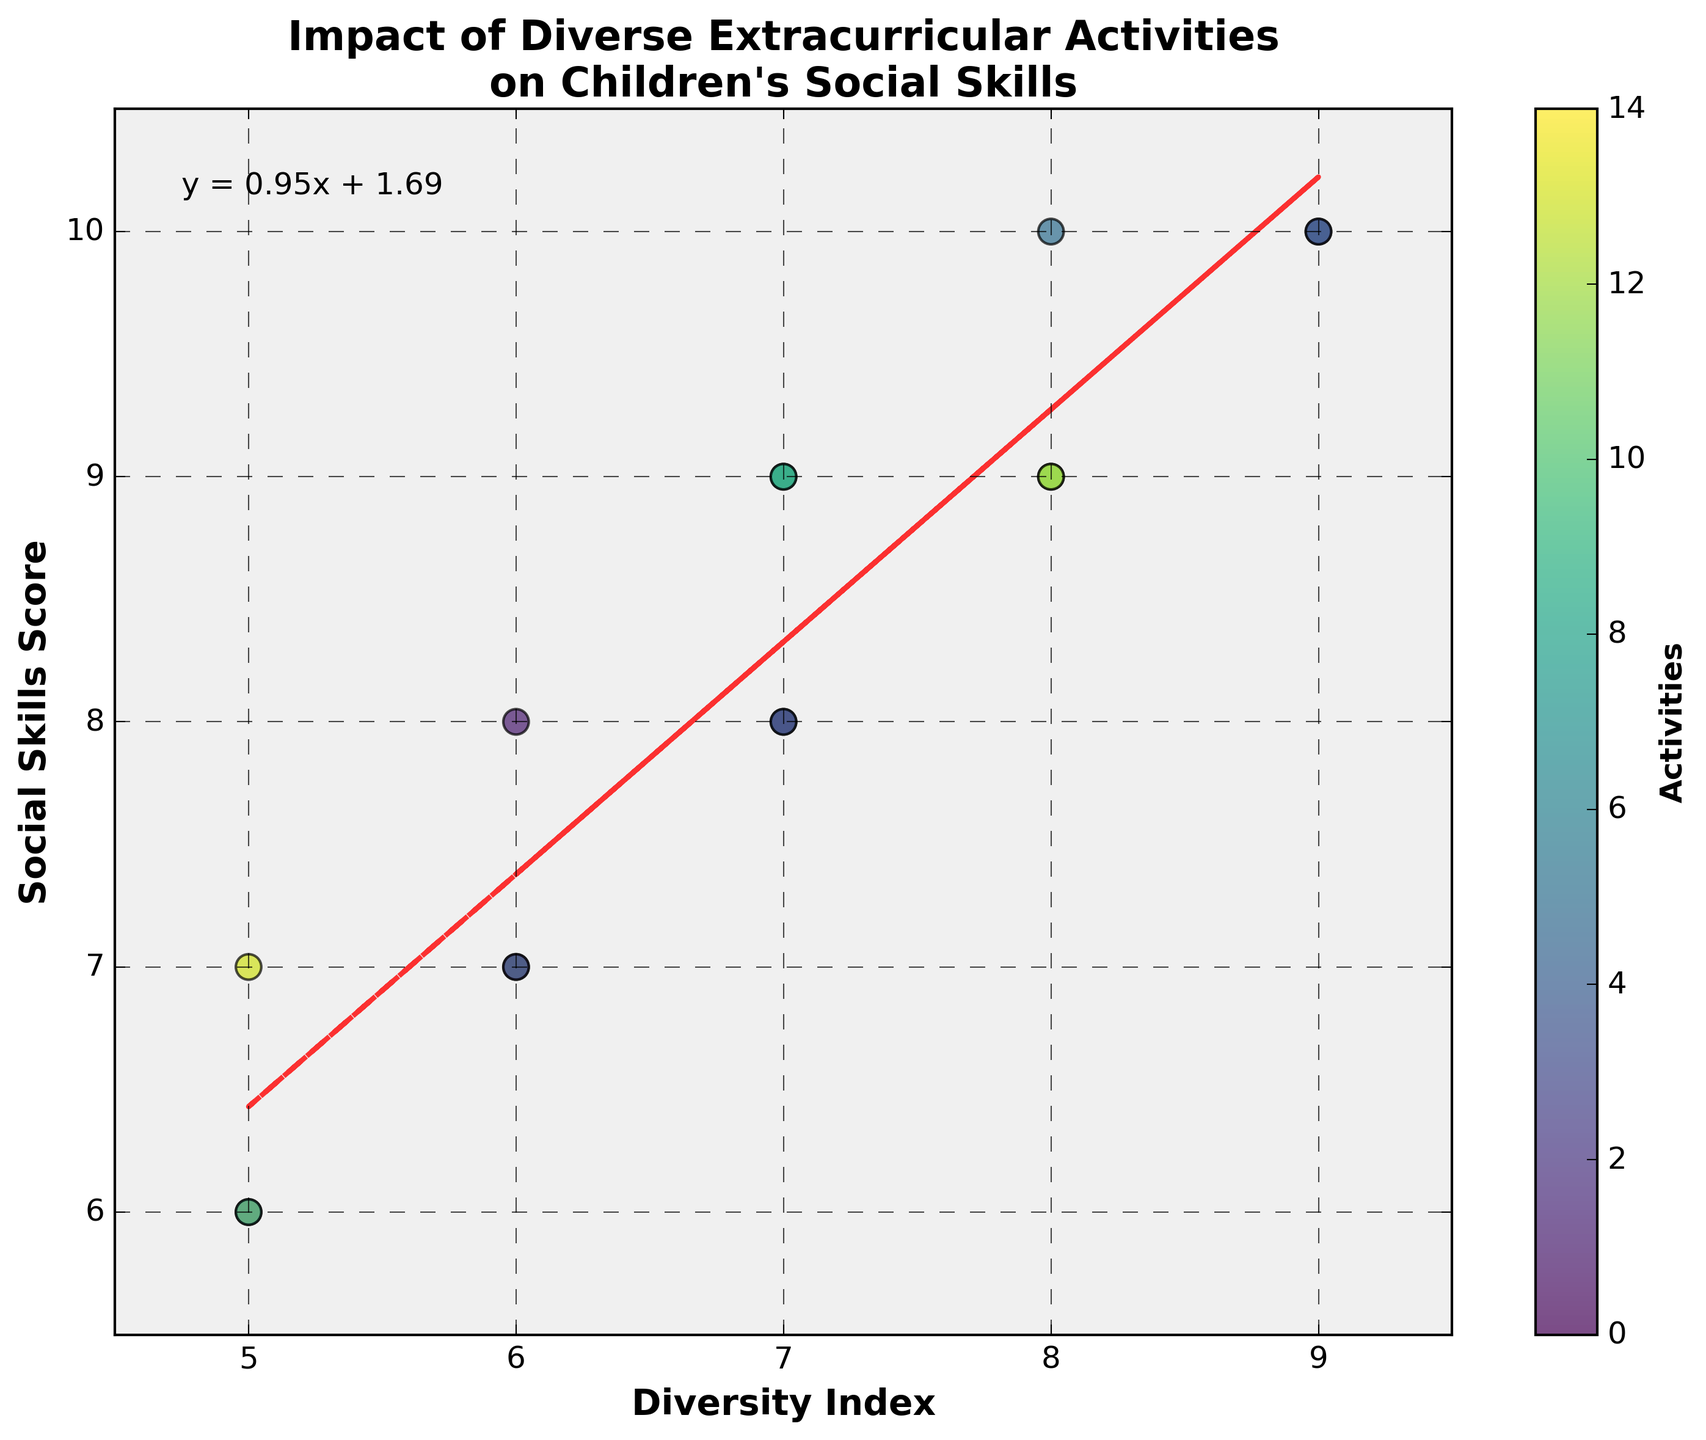How many activities are represented in the scatter plot? Count the number of unique data points in the scatter plot. Each point represents a different activity.
Answer: 15 What is the title of the scatter plot? Read the title text displayed at the top of the scatter plot.
Answer: Impact of Diverse Extracurricular Activities on Children's Social Skills What is the slope of the trend line? Look at the text annotation on the plot that shows the equation of the trend line and extract the slope value.
Answer: 0.63 Which activity has the highest Social Skills Score? Identify the data point at the highest position on the y-axis and check the corresponding activity.
Answer: Drama Club, Debate Team, Community Service What is the Social Skills Score for the activity with a Diversity Index of 7? Find the data points on the scatter plot where the x-value (Diversity Index) is 7, then note the corresponding y-values (Social Skills Scores).
Answer: 9, 8, 9, 8 What is the range of the Diversity Index in the plot? Determine the minimum and maximum values of the Diversity Index along the x-axis.
Answer: 5 to 9 Is there a positive or negative correlation between Diversity Index and Social Skills Score? Observe the direction of the trend line. A positive slope indicates a positive correlation.
Answer: Positive Which activity has the lowest Social Skills Score? Locate the data point at the lowest position on the y-axis and note the corresponding activity.
Answer: Swimming, Hiking Club What are the Diversity Index and Social Skills Score for Basketball? Find the data point corresponding to Basketball and extract the x-value (Diversity Index) and y-value (Social Skills Score).
Answer: 6, 8 How many activities have a Diversity Index greater than 7? Count the number of data points that have an x-value (Diversity Index) greater than 7.
Answer: 5 